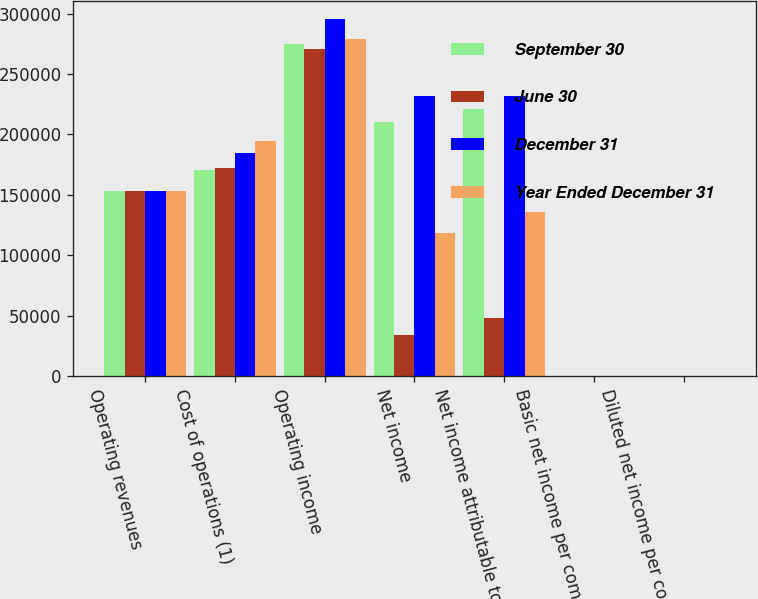Convert chart. <chart><loc_0><loc_0><loc_500><loc_500><stacked_bar_chart><ecel><fcel>Operating revenues<fcel>Cost of operations (1)<fcel>Operating income<fcel>Net income<fcel>Net income attributable to<fcel>Basic net income per common<fcel>Diluted net income per common<nl><fcel>September 30<fcel>153332<fcel>170985<fcel>274446<fcel>210358<fcel>221306<fcel>0.56<fcel>0.56<nl><fcel>June 30<fcel>153332<fcel>172384<fcel>270486<fcel>33689<fcel>48209<fcel>0.12<fcel>0.12<nl><fcel>December 31<fcel>153332<fcel>184904<fcel>295552<fcel>231825<fcel>232089<fcel>0.59<fcel>0.58<nl><fcel>Year Ended December 31<fcel>153332<fcel>194206<fcel>279235<fcel>118153<fcel>135679<fcel>0.34<fcel>0.34<nl></chart> 